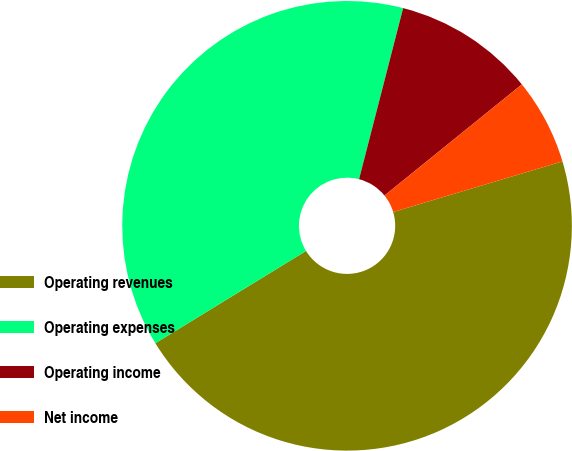Convert chart to OTSL. <chart><loc_0><loc_0><loc_500><loc_500><pie_chart><fcel>Operating revenues<fcel>Operating expenses<fcel>Operating income<fcel>Net income<nl><fcel>45.88%<fcel>37.76%<fcel>10.16%<fcel>6.2%<nl></chart> 